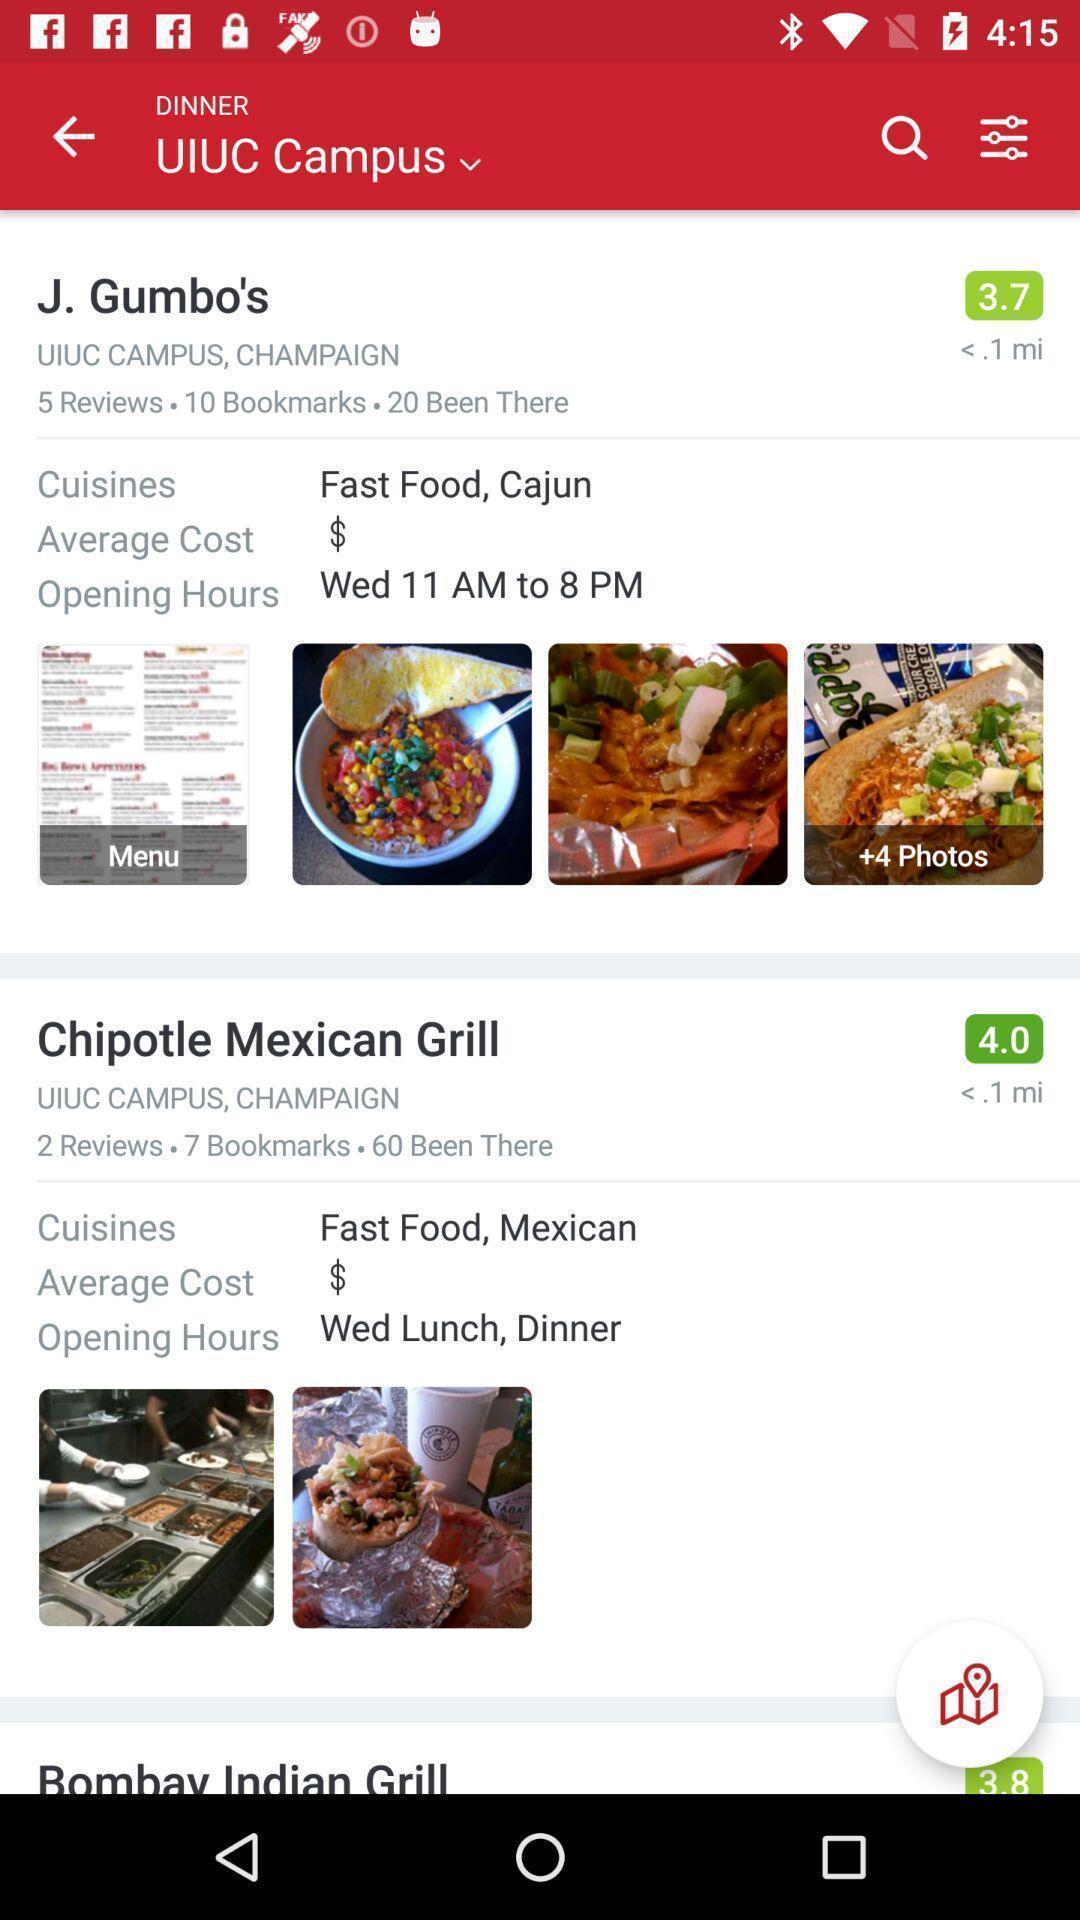Describe the content in this image. Screen shows a page of an online food app. 